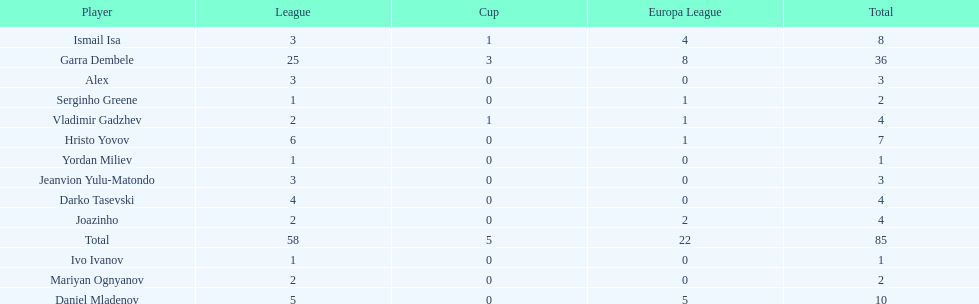Which players have at least 4 in the europa league? Garra Dembele, Daniel Mladenov, Ismail Isa. 